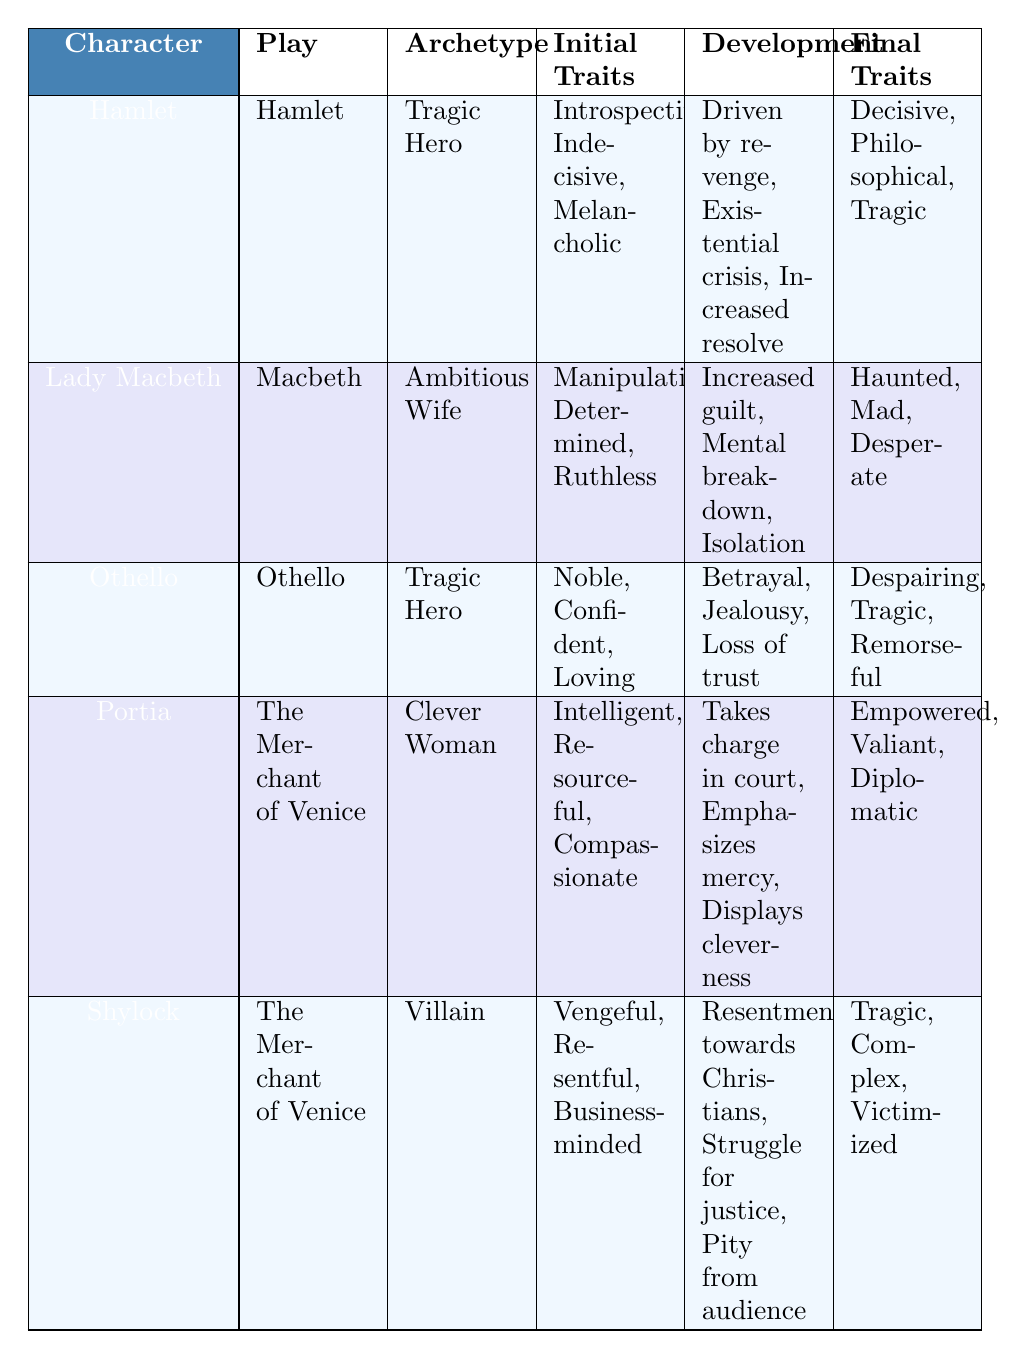What archetype is Hamlet associated with? The table indicates that Hamlet's archetype is listed under the Archetype column as "Tragic Hero."
Answer: Tragic Hero Which character shows an increase in guilt throughout their development? The table shows that Lady Macbeth experiences "Increased guilt" in the Development column, indicating she represents this trait.
Answer: Lady Macbeth True or False: Portia's final traits include "Empowered" and "Desperate." The table reflects Portia's final traits as "Empowered, Valiant, Diplomatic," which does not include "Desperate." Therefore, the statement is false.
Answer: False What development characterizes Othello's journey? According to the table, Othello's development includes "Betrayal, Jealousy, Loss of trust." This represents the challenges he faces throughout the play.
Answer: Betrayal, Jealousy, Loss of trust Which character goes through a mental breakdown? The table shows that Lady Macbeth’s development includes "Mental breakdown," indicating this change in her character.
Answer: Lady Macbeth How many total traits does Shylock possess after his development? Shylock’s final traits are "Tragic, Complex, Victimized," which are three traits in total based on the Final Traits column.
Answer: 3 True or False: Othello's initial traits are "Noble, Confident, Loving." The table confirms that Othello's initial traits are indeed "Noble, Confident, Loving," making this statement true.
Answer: True Which character displays cleverness and resourcefulness? The table notes that Portia’s Initial Traits include "Intelligent, Resourceful, Compassionate," and her development emphasizes her "Displays cleverness."
Answer: Portia Among the characters listed, who has a final trait of "Haunted"? The table specifies that Lady Macbeth's final traits include "Haunted," indicating her psychological state at the end of the play.
Answer: Lady Macbeth 